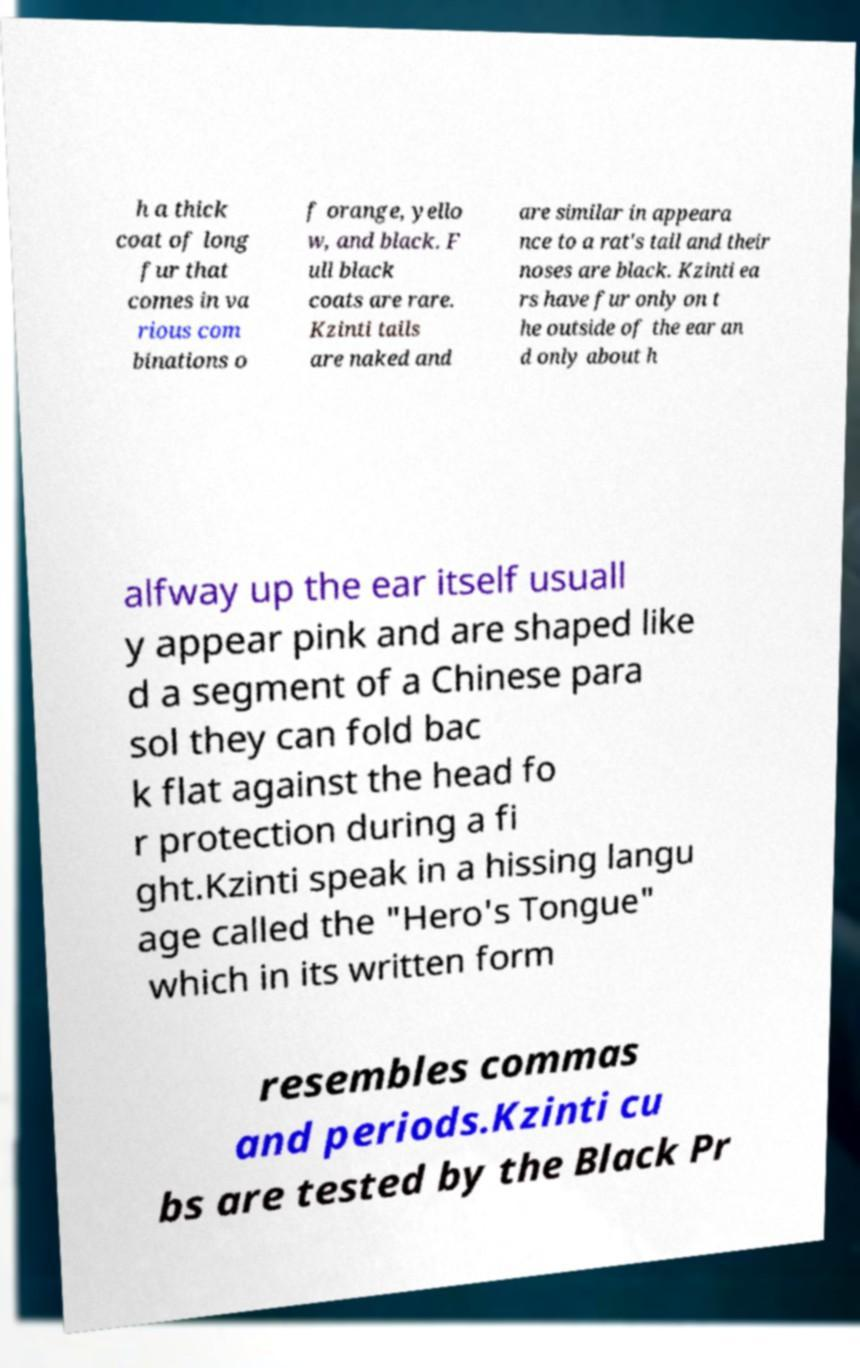Can you read and provide the text displayed in the image?This photo seems to have some interesting text. Can you extract and type it out for me? h a thick coat of long fur that comes in va rious com binations o f orange, yello w, and black. F ull black coats are rare. Kzinti tails are naked and are similar in appeara nce to a rat's tail and their noses are black. Kzinti ea rs have fur only on t he outside of the ear an d only about h alfway up the ear itself usuall y appear pink and are shaped like d a segment of a Chinese para sol they can fold bac k flat against the head fo r protection during a fi ght.Kzinti speak in a hissing langu age called the "Hero's Tongue" which in its written form resembles commas and periods.Kzinti cu bs are tested by the Black Pr 